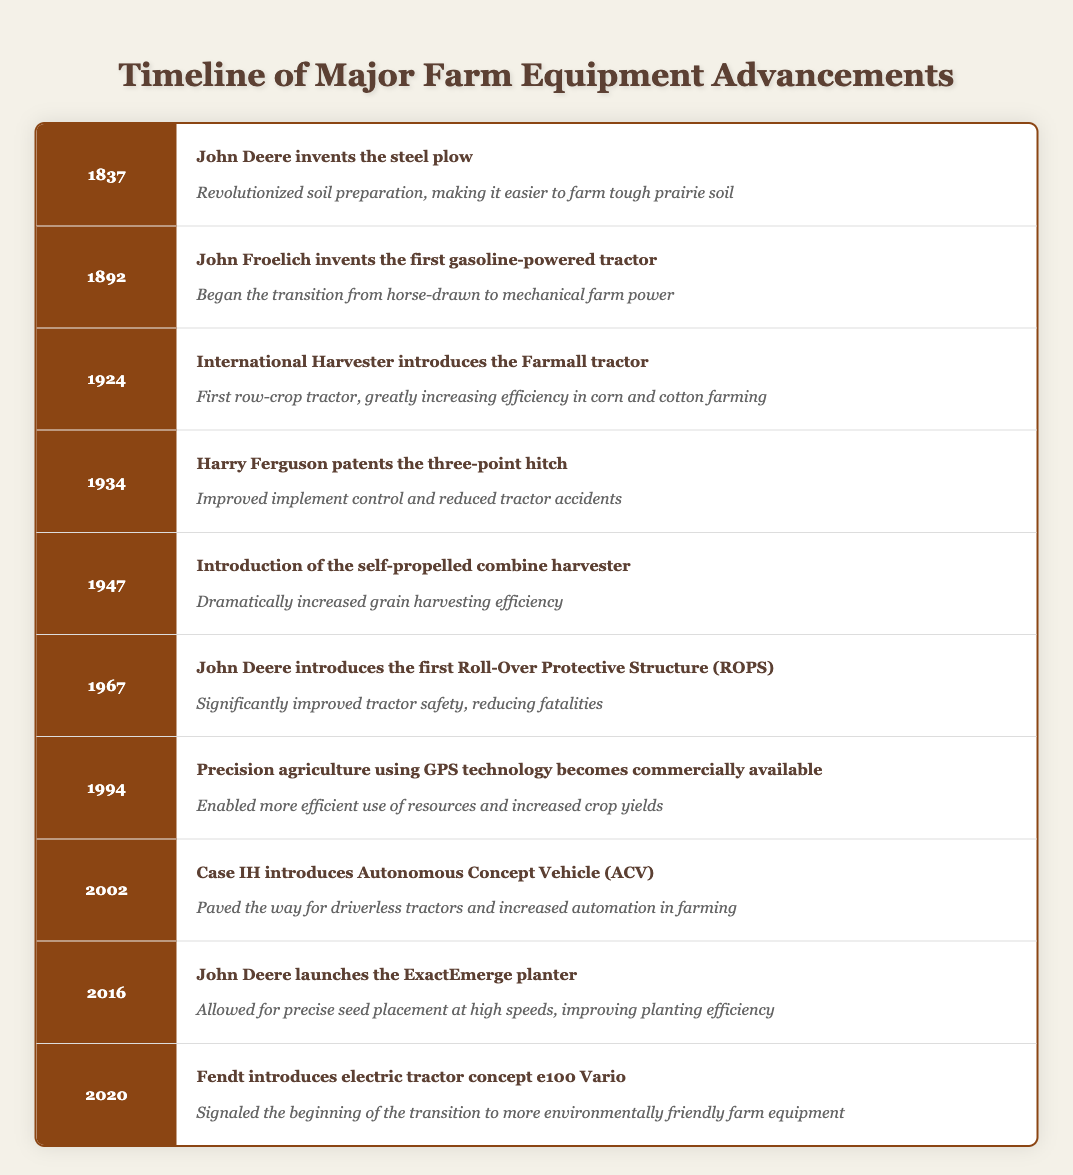What significant farming innovation occurred in 1837? In 1837, John Deere invented the steel plow, which is noted in the timeline as a major event that revolutionized soil preparation and made farming easier in tough prairie soil.
Answer: John Deere invents the steel plow Which farm equipment advancement was introduced in 1947? The timeline shows that in 1947, the introduction of the self-propelled combine harvester occurred, dramatically increasing grain harvesting efficiency.
Answer: Self-propelled combine harvester How many years passed between the invention of the first gasoline-powered tractor and the introduction of precision agriculture using GPS technology? The first gasoline-powered tractor was invented in 1892 and precision agriculture became commercially available in 1994. Calculating the difference: 1994 - 1892 = 102 years.
Answer: 102 years Did the introduction of the first Roll-Over Protective Structure (ROPS) occur before or after the steel plow was invented? The timeline indicates that the steel plow was invented in 1837 and the first Roll-Over Protective Structure (ROPS) was introduced in 1967. Since 1837 is before 1967, the statement is true.
Answer: Yes Which equipment advancement marked the beginning of more environmentally friendly farm equipment? The timeline shows that the introduction of the electric tractor concept e100 Vario by Fendt in 2020 marked the beginning of this trend.
Answer: Electric tractor concept e100 Vario What was the impact of Harry Ferguson's three-point hitch invention? The timeline states that Harry Ferguson's three-point hitch, patented in 1934, improved implement control and reduced tractor accidents, enhancing overall safety and functionality in farming.
Answer: Improved implement control and reduced accidents How many technological advancements are listed in the timeline from 1837 to 2020? The timeline presents 10 technological advancements, starting from John Deere's steel plow in 1837 up to Fendt's electric tractor concept in 2020, thus counting the entries gives a total of 10.
Answer: 10 advancements Did John Deere introduce the first Roll-Over Protective Structure (ROPS) after 1960? According to the timeline, John Deere introduced the first ROPS in 1967, which is after 1960. Therefore, the statement is true.
Answer: Yes What was one effect of the precision agriculture technology introduced in 1994? The timeline indicates that precision agriculture allowed for more efficient use of resources and increased crop yields, highlighting its significant impact on farming practices.
Answer: Enabled efficient resource use and increased crop yields 